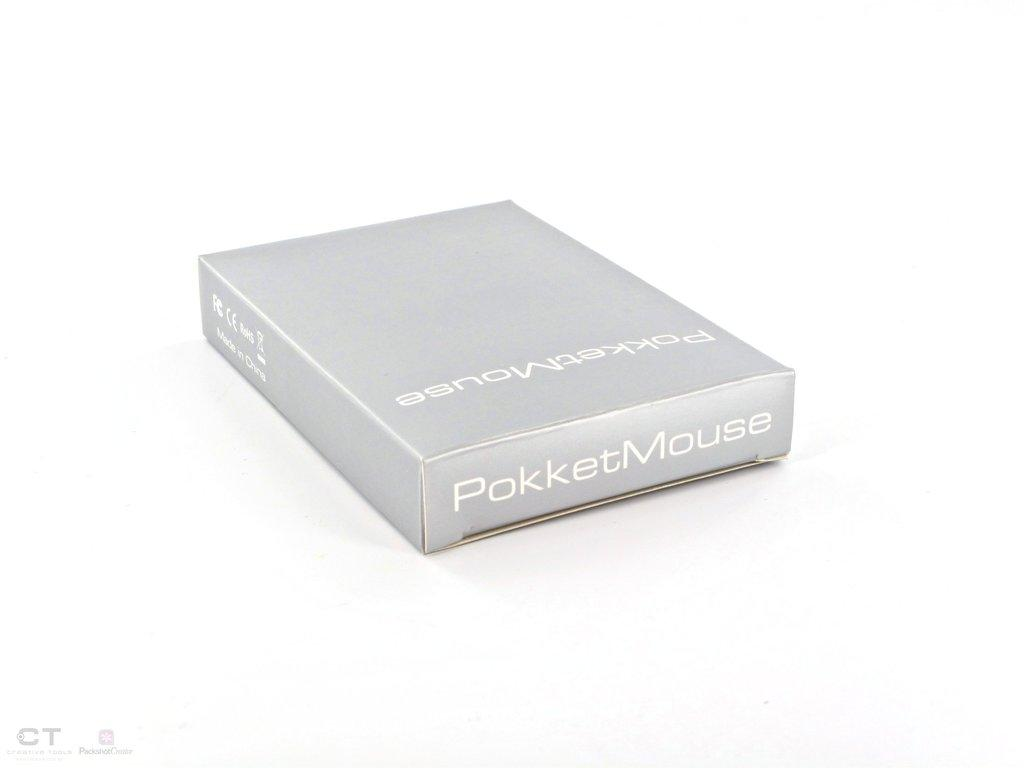<image>
Describe the image concisely. A grey box is labelled "Pokket Mouse" in white text. 